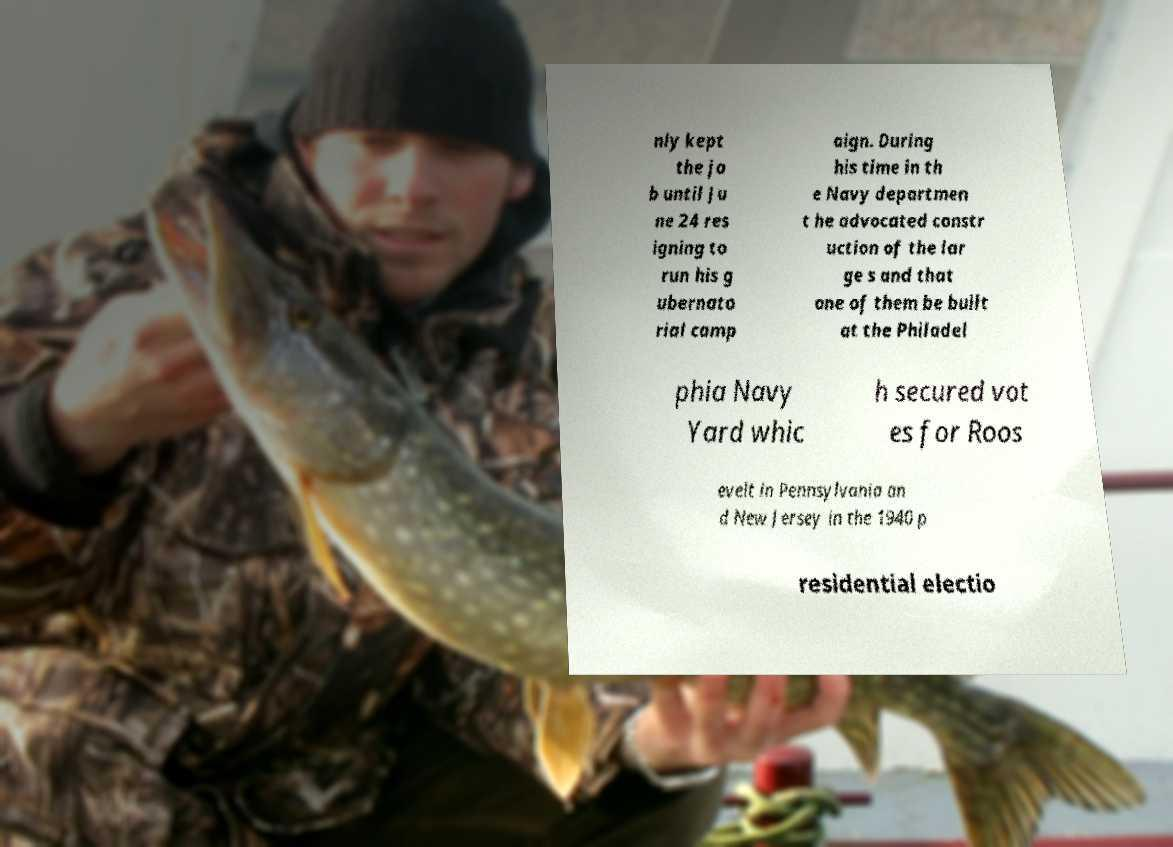Can you read and provide the text displayed in the image?This photo seems to have some interesting text. Can you extract and type it out for me? nly kept the jo b until Ju ne 24 res igning to run his g ubernato rial camp aign. During his time in th e Navy departmen t he advocated constr uction of the lar ge s and that one of them be built at the Philadel phia Navy Yard whic h secured vot es for Roos evelt in Pennsylvania an d New Jersey in the 1940 p residential electio 